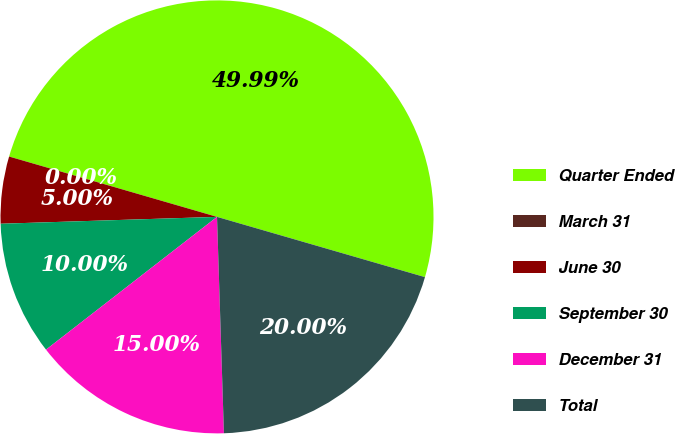Convert chart. <chart><loc_0><loc_0><loc_500><loc_500><pie_chart><fcel>Quarter Ended<fcel>March 31<fcel>June 30<fcel>September 30<fcel>December 31<fcel>Total<nl><fcel>49.99%<fcel>0.0%<fcel>5.0%<fcel>10.0%<fcel>15.0%<fcel>20.0%<nl></chart> 